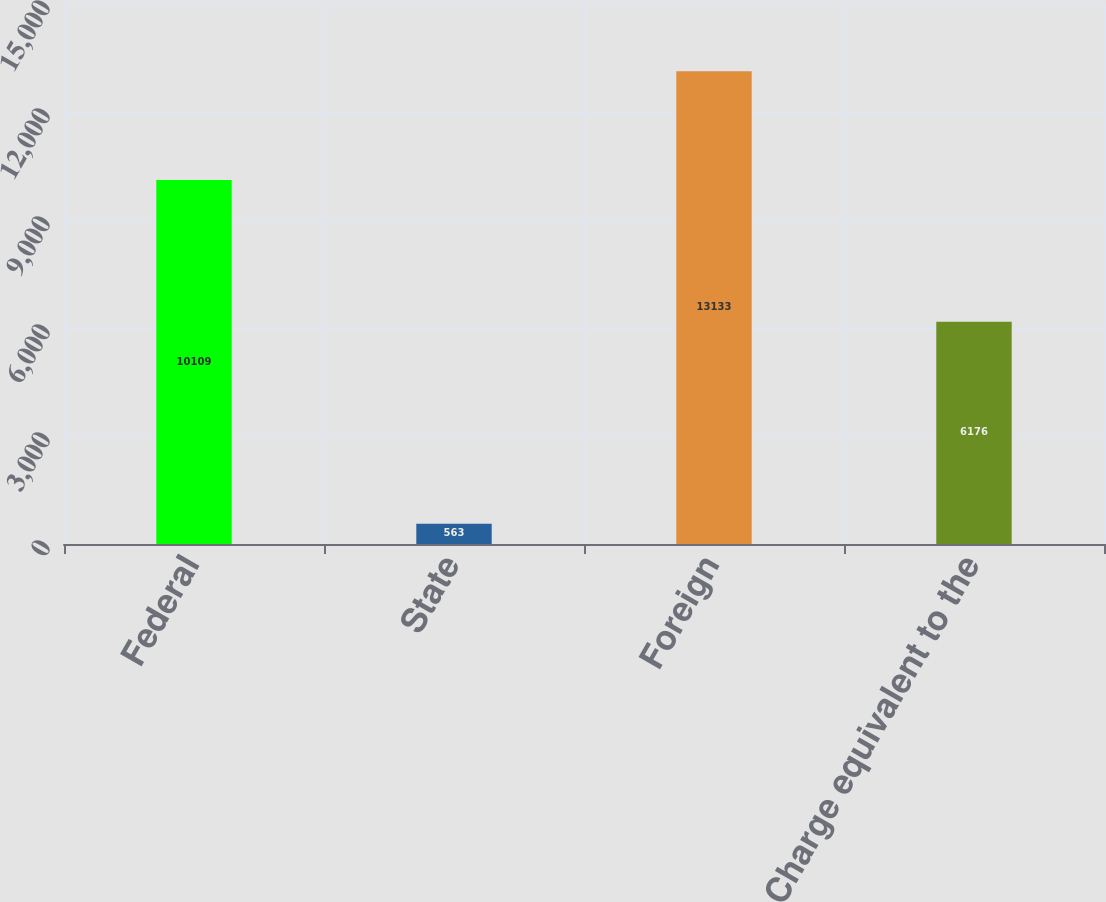Convert chart. <chart><loc_0><loc_0><loc_500><loc_500><bar_chart><fcel>Federal<fcel>State<fcel>Foreign<fcel>Charge equivalent to the<nl><fcel>10109<fcel>563<fcel>13133<fcel>6176<nl></chart> 